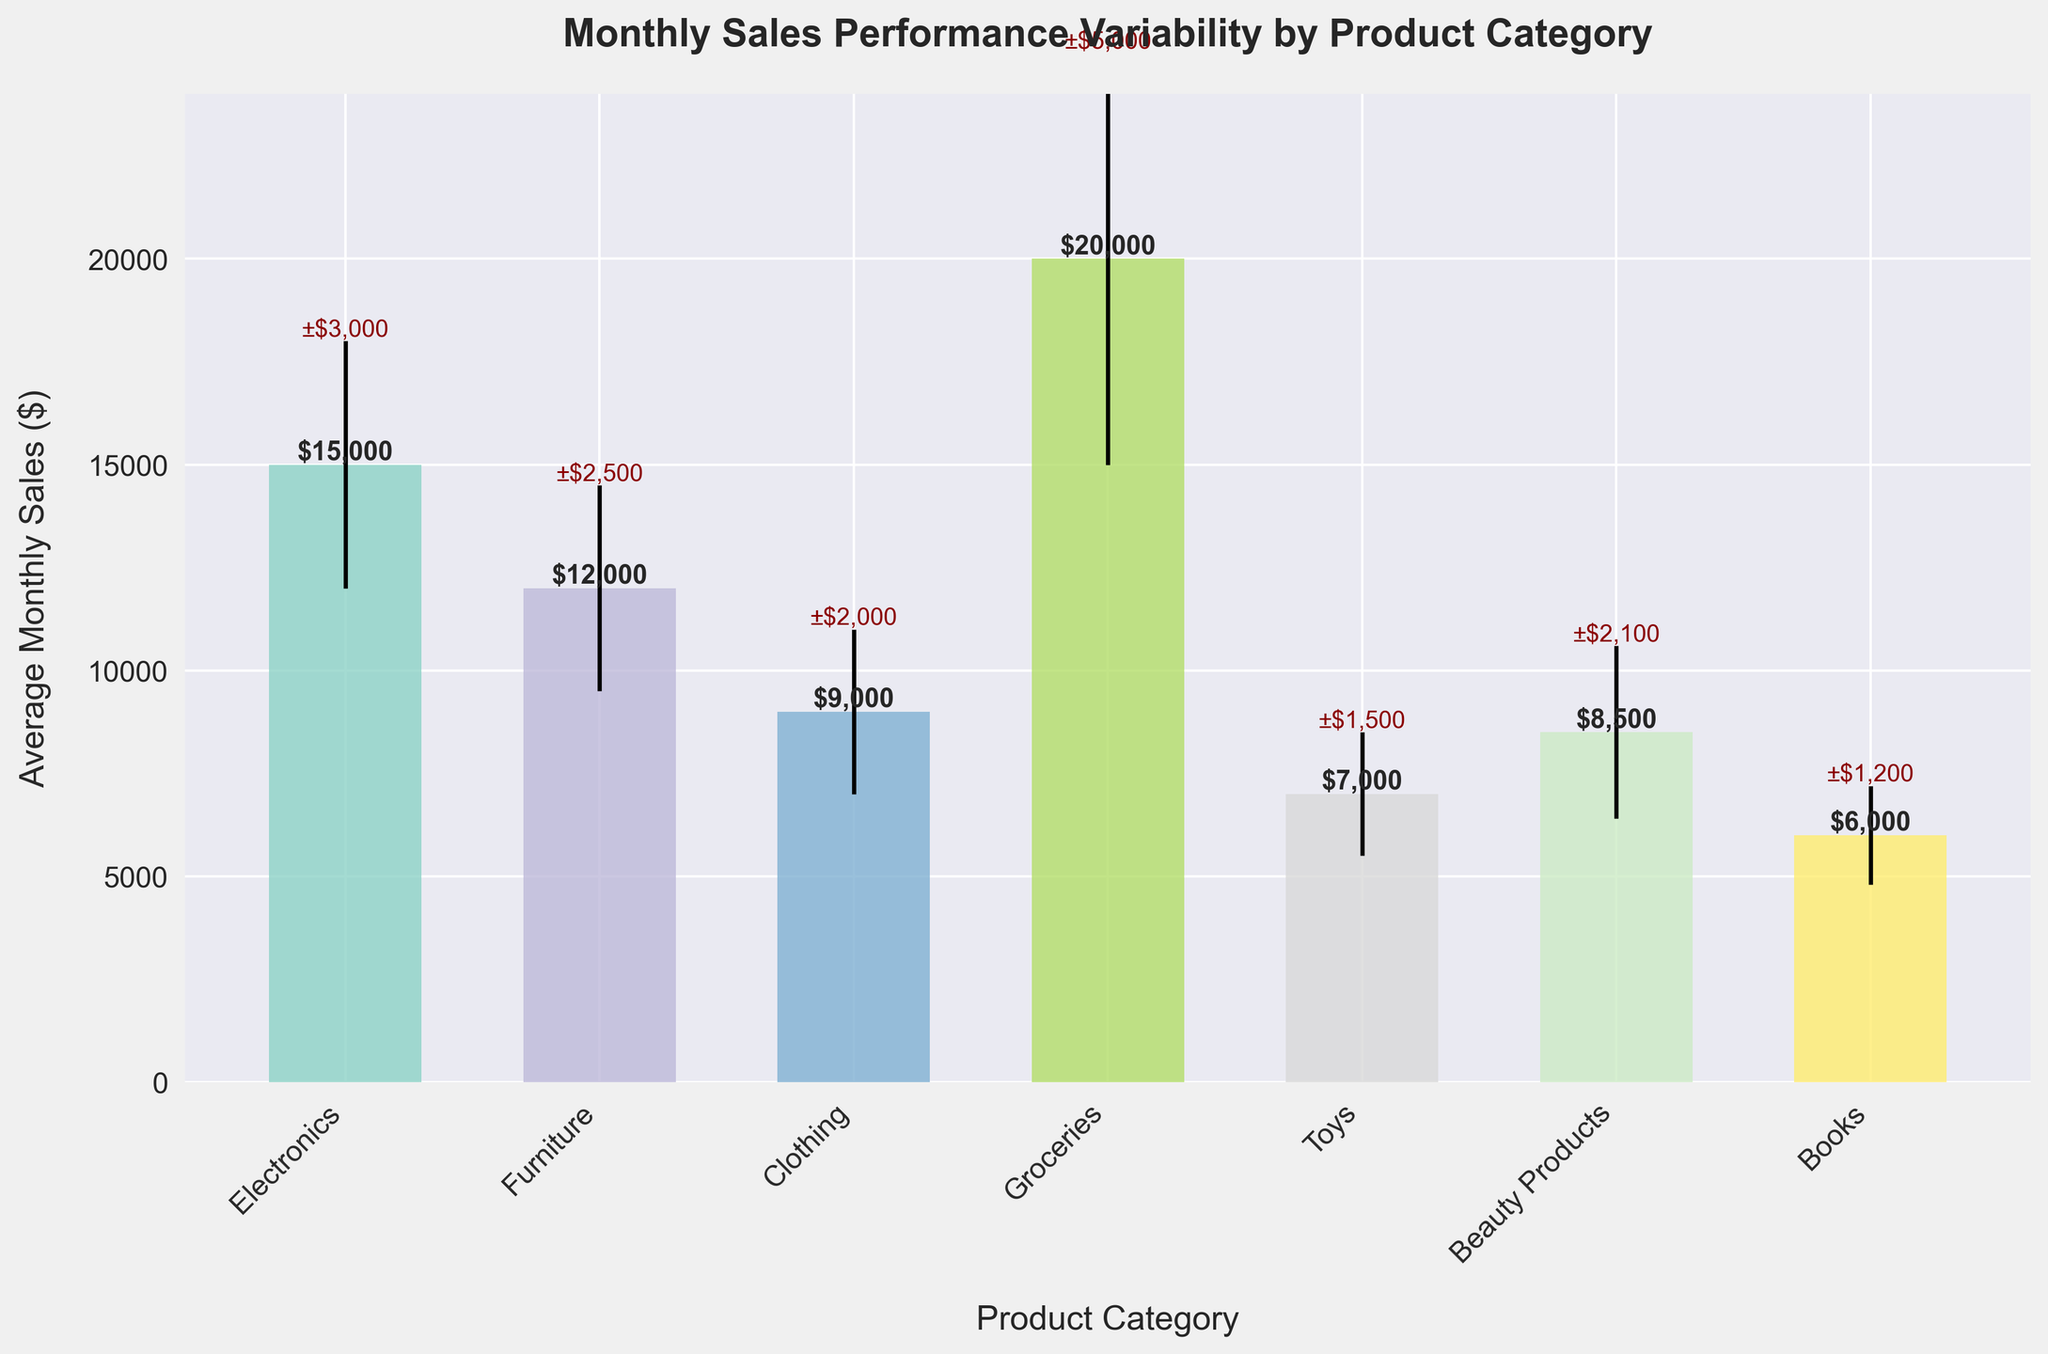What is the title of the bar chart? The title is found at the top of the chart. It provides an overview of what the chart is about.
Answer: Monthly Sales Performance Variability by Product Category Which product category has the highest average monthly sales? By looking at the height of the bars, the highest bar represents the category with the highest average sales.
Answer: Groceries What is the standard deviation for the Toys category? The standard deviation is depicted by the error bars at the top of the bar. The text near the error bar of the Toys category shows its value.
Answer: 1500 Which product category has the lowest average monthly sales and what is its value? The lowest bar represents the category with the lowest average sales, and the height of this bar gives the value.
Answer: Books, $6000 Which product category has the largest variability (highest standard deviation) in monthly sales? The category with the largest error bar height (standard deviation value) has the largest variability.
Answer: Groceries 